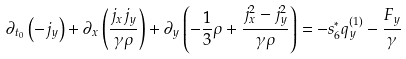<formula> <loc_0><loc_0><loc_500><loc_500>\partial _ { t _ { 0 } } \left ( - j _ { y } \right ) + \partial _ { x } \left ( \frac { j _ { x } j _ { y } } { \gamma \rho } \right ) + \partial _ { y } \left ( - \frac { 1 } { 3 } \rho + \frac { j _ { x } ^ { 2 } - j _ { y } ^ { 2 } } { \gamma \rho } \right ) = - s _ { 6 } ^ { * } q _ { y } ^ { ( 1 ) } - \frac { F _ { y } } { \gamma }</formula> 